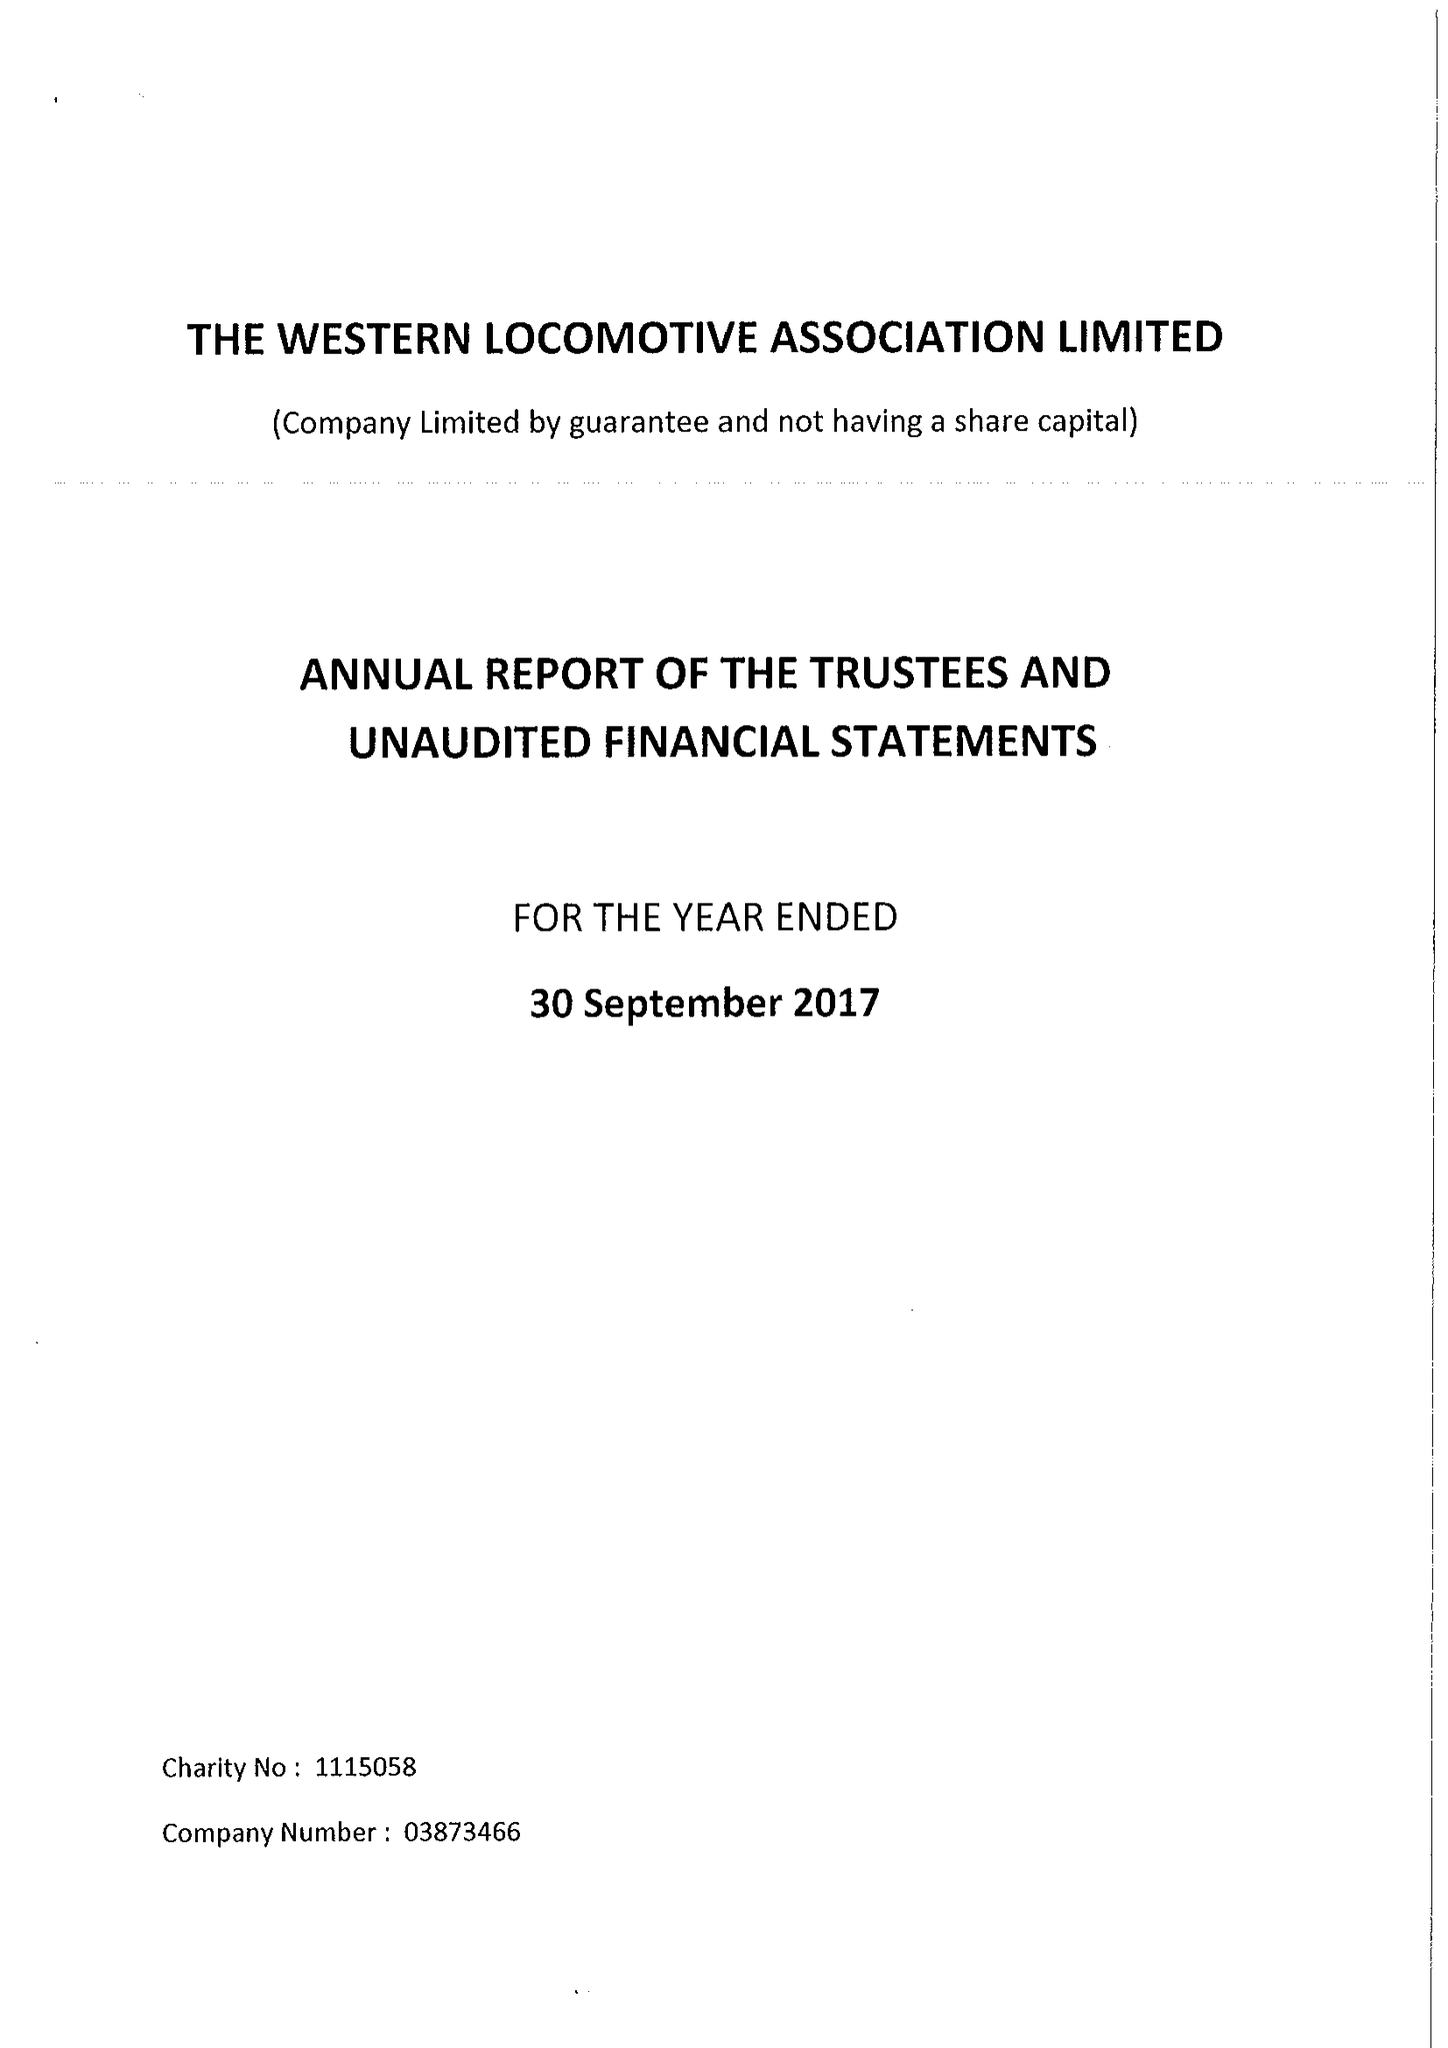What is the value for the charity_number?
Answer the question using a single word or phrase. 1115058 